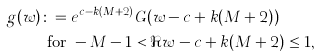<formula> <loc_0><loc_0><loc_500><loc_500>g ( w ) & \colon = e ^ { c - k ( M + 2 ) } G ( w - c + k ( M + 2 ) ) \\ & \text { for } - M - 1 < \Re w - c + k ( M + 2 ) \leq 1 ,</formula> 